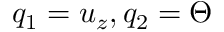<formula> <loc_0><loc_0><loc_500><loc_500>q _ { 1 } = u _ { z } , q _ { 2 } = \Theta</formula> 